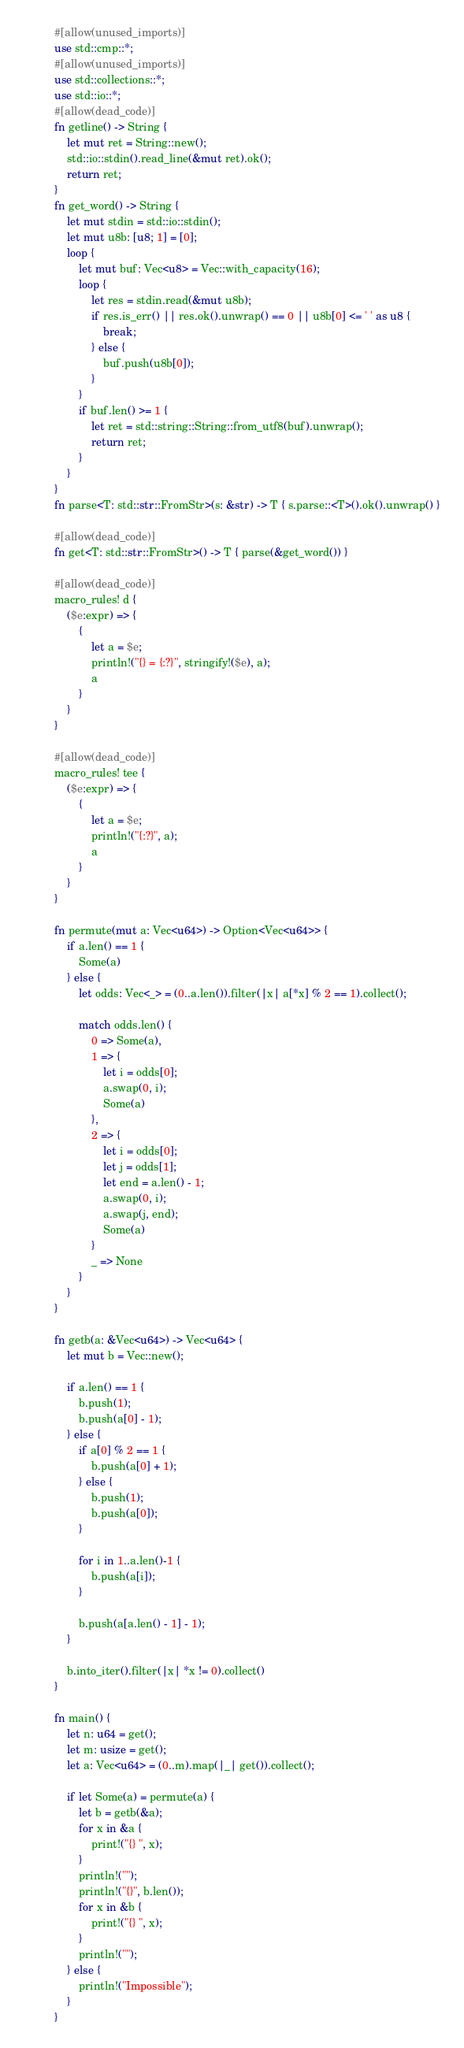Convert code to text. <code><loc_0><loc_0><loc_500><loc_500><_Rust_>#[allow(unused_imports)]
use std::cmp::*;
#[allow(unused_imports)]
use std::collections::*;
use std::io::*;
#[allow(dead_code)]
fn getline() -> String {
    let mut ret = String::new();
    std::io::stdin().read_line(&mut ret).ok();
    return ret;
}
fn get_word() -> String {
    let mut stdin = std::io::stdin();
    let mut u8b: [u8; 1] = [0];
    loop {
        let mut buf: Vec<u8> = Vec::with_capacity(16);
        loop {
            let res = stdin.read(&mut u8b);
            if res.is_err() || res.ok().unwrap() == 0 || u8b[0] <= ' ' as u8 {
                break;
            } else {
                buf.push(u8b[0]);
            }
        }
        if buf.len() >= 1 {
            let ret = std::string::String::from_utf8(buf).unwrap();
            return ret;
        }
    }
}
fn parse<T: std::str::FromStr>(s: &str) -> T { s.parse::<T>().ok().unwrap() }

#[allow(dead_code)]
fn get<T: std::str::FromStr>() -> T { parse(&get_word()) }

#[allow(dead_code)]
macro_rules! d {
    ($e:expr) => {
        {
            let a = $e;
            println!("{} = {:?}", stringify!($e), a);
            a
        }
    }
}

#[allow(dead_code)]
macro_rules! tee {
    ($e:expr) => {
        {
            let a = $e;
            println!("{:?}", a);
            a
        }
    }
}

fn permute(mut a: Vec<u64>) -> Option<Vec<u64>> {
    if a.len() == 1 {
        Some(a)
    } else {
        let odds: Vec<_> = (0..a.len()).filter(|x| a[*x] % 2 == 1).collect();

        match odds.len() {
            0 => Some(a),
            1 => {
                let i = odds[0];
                a.swap(0, i);
                Some(a)
            },
            2 => {
                let i = odds[0];
                let j = odds[1];
                let end = a.len() - 1;
                a.swap(0, i);
                a.swap(j, end);
                Some(a)
            }
            _ => None
        }
    }
}

fn getb(a: &Vec<u64>) -> Vec<u64> {
    let mut b = Vec::new();

    if a.len() == 1 {
        b.push(1);
        b.push(a[0] - 1);
    } else {
        if a[0] % 2 == 1 {
            b.push(a[0] + 1);
        } else {
            b.push(1);
            b.push(a[0]);
        }

        for i in 1..a.len()-1 {
            b.push(a[i]);
        }

        b.push(a[a.len() - 1] - 1);
    }

    b.into_iter().filter(|x| *x != 0).collect()
}

fn main() {
    let n: u64 = get();
    let m: usize = get();
    let a: Vec<u64> = (0..m).map(|_| get()).collect();

    if let Some(a) = permute(a) {
        let b = getb(&a);
        for x in &a {
            print!("{} ", x);
        }
        println!("");
        println!("{}", b.len());
        for x in &b {
            print!("{} ", x);
        }
        println!("");
    } else {
        println!("Impossible");
    }
}
</code> 